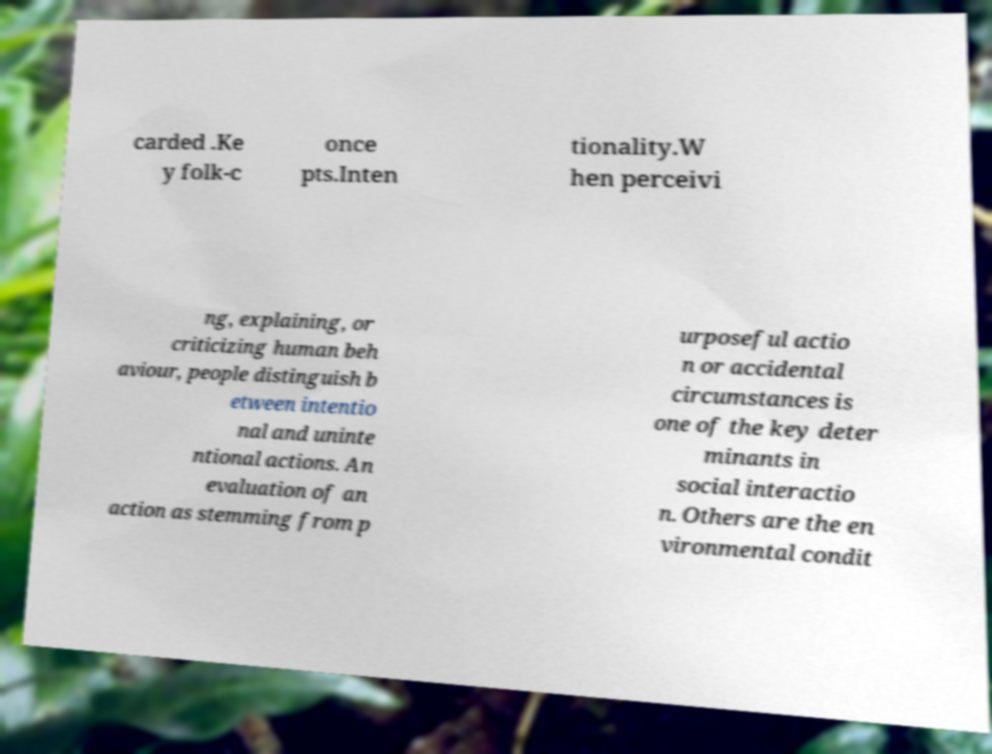Could you extract and type out the text from this image? carded .Ke y folk-c once pts.Inten tionality.W hen perceivi ng, explaining, or criticizing human beh aviour, people distinguish b etween intentio nal and uninte ntional actions. An evaluation of an action as stemming from p urposeful actio n or accidental circumstances is one of the key deter minants in social interactio n. Others are the en vironmental condit 